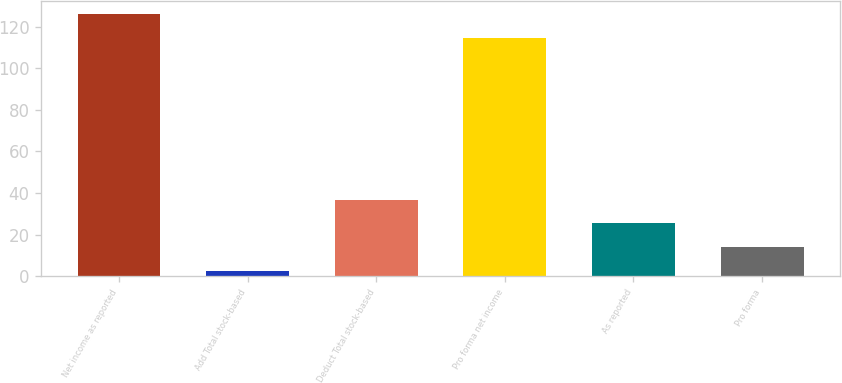Convert chart to OTSL. <chart><loc_0><loc_0><loc_500><loc_500><bar_chart><fcel>Net income as reported<fcel>Add Total stock-based<fcel>Deduct Total stock-based<fcel>Pro forma net income<fcel>As reported<fcel>Pro forma<nl><fcel>125.99<fcel>2.7<fcel>36.87<fcel>114.6<fcel>25.48<fcel>14.09<nl></chart> 